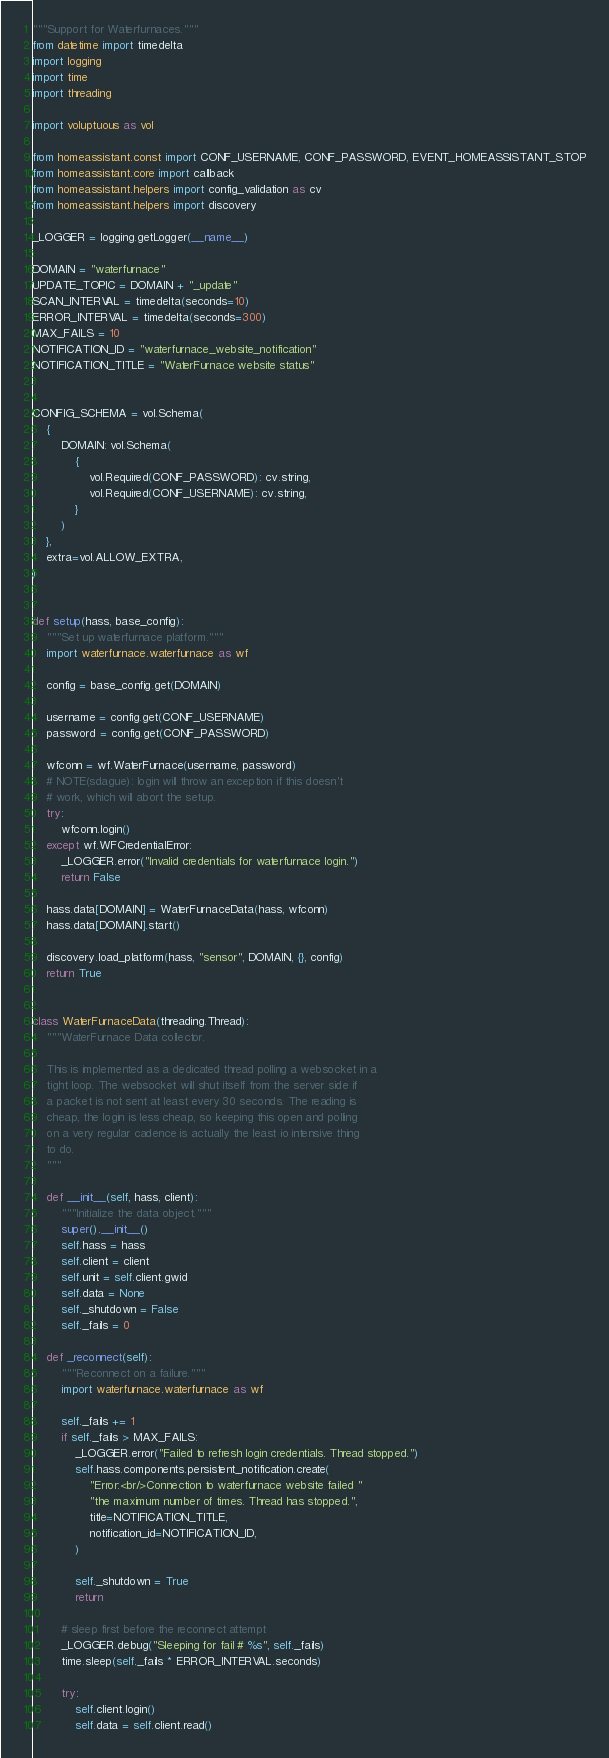<code> <loc_0><loc_0><loc_500><loc_500><_Python_>"""Support for Waterfurnaces."""
from datetime import timedelta
import logging
import time
import threading

import voluptuous as vol

from homeassistant.const import CONF_USERNAME, CONF_PASSWORD, EVENT_HOMEASSISTANT_STOP
from homeassistant.core import callback
from homeassistant.helpers import config_validation as cv
from homeassistant.helpers import discovery

_LOGGER = logging.getLogger(__name__)

DOMAIN = "waterfurnace"
UPDATE_TOPIC = DOMAIN + "_update"
SCAN_INTERVAL = timedelta(seconds=10)
ERROR_INTERVAL = timedelta(seconds=300)
MAX_FAILS = 10
NOTIFICATION_ID = "waterfurnace_website_notification"
NOTIFICATION_TITLE = "WaterFurnace website status"


CONFIG_SCHEMA = vol.Schema(
    {
        DOMAIN: vol.Schema(
            {
                vol.Required(CONF_PASSWORD): cv.string,
                vol.Required(CONF_USERNAME): cv.string,
            }
        )
    },
    extra=vol.ALLOW_EXTRA,
)


def setup(hass, base_config):
    """Set up waterfurnace platform."""
    import waterfurnace.waterfurnace as wf

    config = base_config.get(DOMAIN)

    username = config.get(CONF_USERNAME)
    password = config.get(CONF_PASSWORD)

    wfconn = wf.WaterFurnace(username, password)
    # NOTE(sdague): login will throw an exception if this doesn't
    # work, which will abort the setup.
    try:
        wfconn.login()
    except wf.WFCredentialError:
        _LOGGER.error("Invalid credentials for waterfurnace login.")
        return False

    hass.data[DOMAIN] = WaterFurnaceData(hass, wfconn)
    hass.data[DOMAIN].start()

    discovery.load_platform(hass, "sensor", DOMAIN, {}, config)
    return True


class WaterFurnaceData(threading.Thread):
    """WaterFurnace Data collector.

    This is implemented as a dedicated thread polling a websocket in a
    tight loop. The websocket will shut itself from the server side if
    a packet is not sent at least every 30 seconds. The reading is
    cheap, the login is less cheap, so keeping this open and polling
    on a very regular cadence is actually the least io intensive thing
    to do.
    """

    def __init__(self, hass, client):
        """Initialize the data object."""
        super().__init__()
        self.hass = hass
        self.client = client
        self.unit = self.client.gwid
        self.data = None
        self._shutdown = False
        self._fails = 0

    def _reconnect(self):
        """Reconnect on a failure."""
        import waterfurnace.waterfurnace as wf

        self._fails += 1
        if self._fails > MAX_FAILS:
            _LOGGER.error("Failed to refresh login credentials. Thread stopped.")
            self.hass.components.persistent_notification.create(
                "Error:<br/>Connection to waterfurnace website failed "
                "the maximum number of times. Thread has stopped.",
                title=NOTIFICATION_TITLE,
                notification_id=NOTIFICATION_ID,
            )

            self._shutdown = True
            return

        # sleep first before the reconnect attempt
        _LOGGER.debug("Sleeping for fail # %s", self._fails)
        time.sleep(self._fails * ERROR_INTERVAL.seconds)

        try:
            self.client.login()
            self.data = self.client.read()</code> 